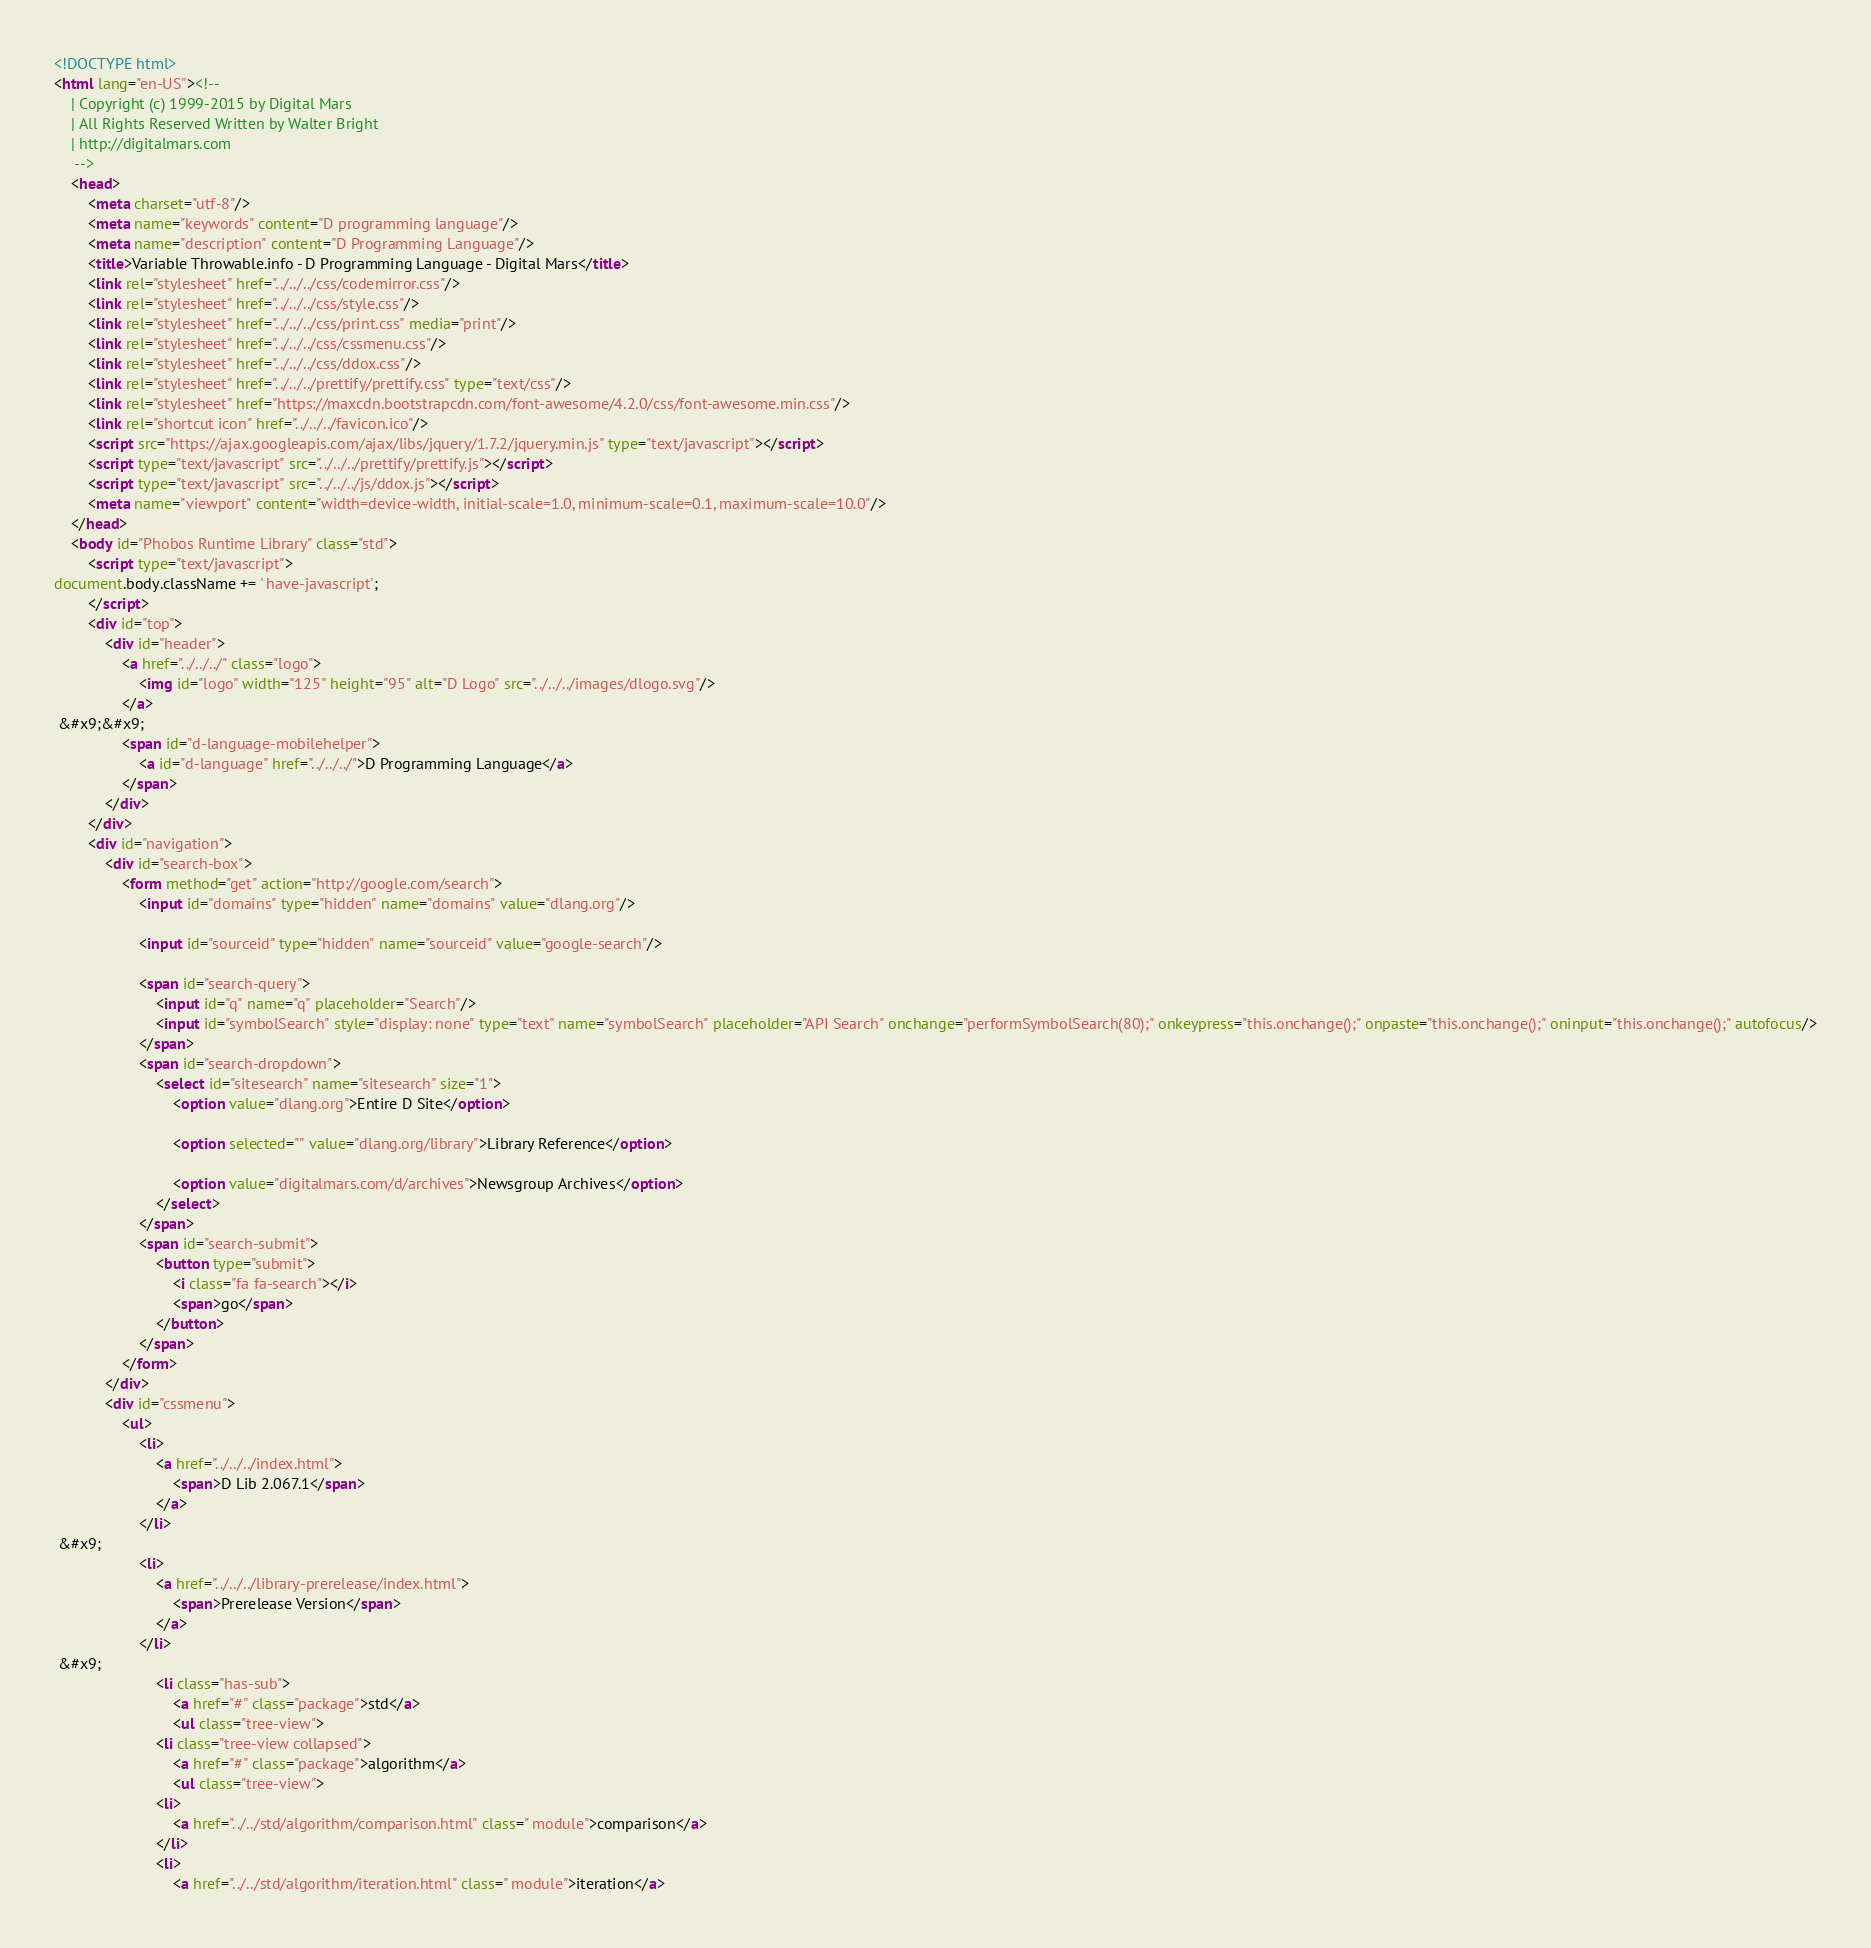<code> <loc_0><loc_0><loc_500><loc_500><_HTML_><!DOCTYPE html>
<html lang="en-US"><!-- 
    | Copyright (c) 1999-2015 by Digital Mars
    | All Rights Reserved Written by Walter Bright
    | http://digitalmars.com
	 -->
	<head>
		<meta charset="utf-8"/>
		<meta name="keywords" content="D programming language"/>
		<meta name="description" content="D Programming Language"/>
		<title>Variable Throwable.info - D Programming Language - Digital Mars</title>
		<link rel="stylesheet" href="../../../css/codemirror.css"/>
		<link rel="stylesheet" href="../../../css/style.css"/>
		<link rel="stylesheet" href="../../../css/print.css" media="print"/>
		<link rel="stylesheet" href="../../../css/cssmenu.css"/>
		<link rel="stylesheet" href="../../../css/ddox.css"/>
		<link rel="stylesheet" href="../../../prettify/prettify.css" type="text/css"/>
		<link rel="stylesheet" href="https://maxcdn.bootstrapcdn.com/font-awesome/4.2.0/css/font-awesome.min.css"/>
		<link rel="shortcut icon" href="../../../favicon.ico"/>
		<script src="https://ajax.googleapis.com/ajax/libs/jquery/1.7.2/jquery.min.js" type="text/javascript"></script>
		<script type="text/javascript" src="../../../prettify/prettify.js"></script>
		<script type="text/javascript" src="../../../js/ddox.js"></script>
		<meta name="viewport" content="width=device-width, initial-scale=1.0, minimum-scale=0.1, maximum-scale=10.0"/>
	</head>
	<body id="Phobos Runtime Library" class="std">
		<script type="text/javascript">
document.body.className += ' have-javascript';
		</script>
		<div id="top">
			<div id="header">
				<a href="../../../" class="logo">
					<img id="logo" width="125" height="95" alt="D Logo" src="../../../images/dlogo.svg"/>
				</a>
 &#x9;&#x9;
				<span id="d-language-mobilehelper">
					<a id="d-language" href="../../../">D Programming Language</a>
				</span>
			</div>
		</div>
		<div id="navigation">
			<div id="search-box">
				<form method="get" action="http://google.com/search">
					<input id="domains" type="hidden" name="domains" value="dlang.org"/>
             
					<input id="sourceid" type="hidden" name="sourceid" value="google-search"/>
             
					<span id="search-query">
						<input id="q" name="q" placeholder="Search"/>
						<input id="symbolSearch" style="display: none" type="text" name="symbolSearch" placeholder="API Search" onchange="performSymbolSearch(80);" onkeypress="this.onchange();" onpaste="this.onchange();" oninput="this.onchange();" autofocus/>
					</span>
					<span id="search-dropdown">
						<select id="sitesearch" name="sitesearch" size="1">
							<option value="dlang.org">Entire D Site</option>
                     
							<option selected="" value="dlang.org/library">Library Reference</option>
                     
							<option value="digitalmars.com/d/archives">Newsgroup Archives</option>
						</select>
					</span>
					<span id="search-submit">
						<button type="submit">
							<i class="fa fa-search"></i>
							<span>go</span>
						</button>
					</span>
				</form>
			</div>
			<div id="cssmenu">
				<ul>
					<li>
						<a href="../../../index.html">
							<span>D Lib 2.067.1</span>
						</a>
					</li>
 &#x9;
					<li>
						<a href="../../../library-prerelease/index.html">
							<span>Prerelease Version</span>
						</a>
					</li>
 &#x9;
						<li class="has-sub">
							<a href="#" class="package">std</a>
							<ul class="tree-view">
						<li class="tree-view collapsed">
							<a href="#" class="package">algorithm</a>
							<ul class="tree-view">
						<li>
							<a href="../../std/algorithm/comparison.html" class=" module">comparison</a>
						</li>
						<li>
							<a href="../../std/algorithm/iteration.html" class=" module">iteration</a></code> 